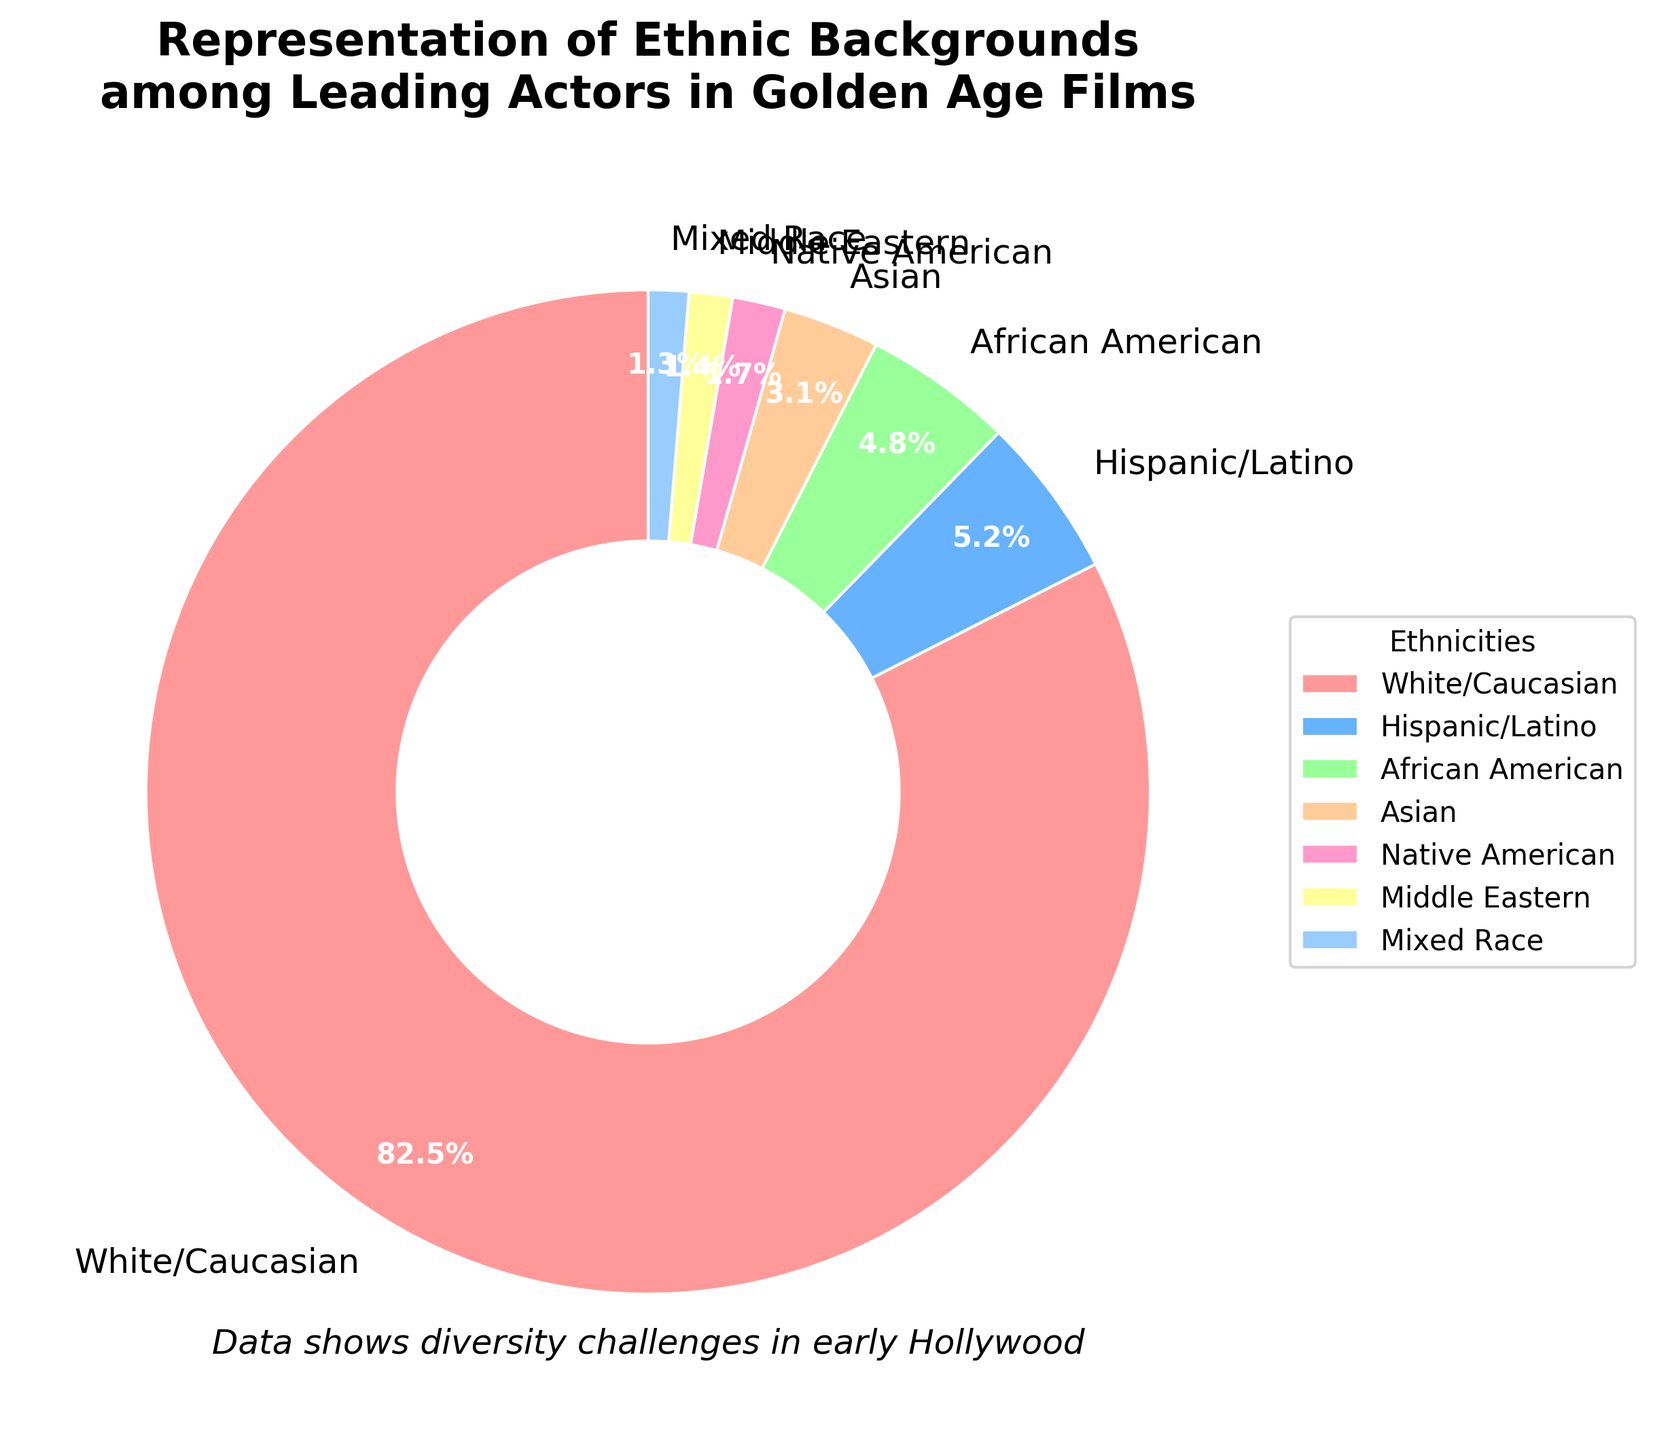What is the most represented ethnic group among leading actors in Golden Age films? The pie chart indicates that the largest segment is labeled "White/Caucasian." With the majority portion, it suggests this ethnic group is the most represented.
Answer: White/Caucasian Which ethnic group has the smallest representation among leading actors in Golden Age films? By examining the pie chart, the smallest segment is labeled "Mixed Race." This indicates it has the least representation.
Answer: Mixed Race How does the representation of Hispanic/Latino actors compare to African American actors? The pie chart shows that Hispanic/Latino actors represent 5.2% and African American actors represent 4.8%. Comparing these values, Hispanic/Latino representation is slightly higher.
Answer: Hispanic/Latino has a higher representation What is the combined percentage of African American and Asian actors? The pie chart indicates that African American actors represent 4.8% and Asian actors represent 3.1%. Adding these together gives 7.9%.
Answer: 7.9% If you combine the percentages of Native American, Middle Eastern, and Mixed Race actors, what is the total representation percentage? According to the pie chart, Native American actors represent 1.7%, Middle Eastern actors represent 1.4%, and Mixed Race actors represent 1.3%. Adding these together gives 4.4%.
Answer: 4.4% Which ethnic group has just slightly more representation than Asian actors? The pie chart indicates that Asian actors represent 3.1%. The next higher percentage is 4.8% for African American actors.
Answer: African American Are there any ethnic groups that have an equal share of representation? Upon reviewing the chart, no two ethnic groups are shown to have equal percentages. Each ethnic group’s share is distinct.
Answer: No What is the difference in percentage between the White/Caucasian representation and the representation of all other groups combined? The chart shows White/Caucasian at 82.5%. All other groups combined sum up to 17.5%. The difference is 82.5% - 17.5% = 65%.
Answer: 65% What color is used to represent Native American actors in the pie chart? The pie chart uses a specific color palette, where Native American is represented by the fifth segment, which corresponds to the fifth color in the list. From the explanation, #FF99CC translates in natural language to pink.
Answer: Pink What percentage of the representation of Hispanic/Latino and Middle Eastern actors combined is less than the White/Caucasian representation? First, combine the percentages of Hispanic/Latino (5.2%) and Middle Eastern (1.4%) which gives 6.6%. The White/Caucasian segment is at 82.5%, hence the Hispanic/Latino and Middle Eastern combined representation is 82.5% - 6.6% = 75.9% less.
Answer: 75.9% less 